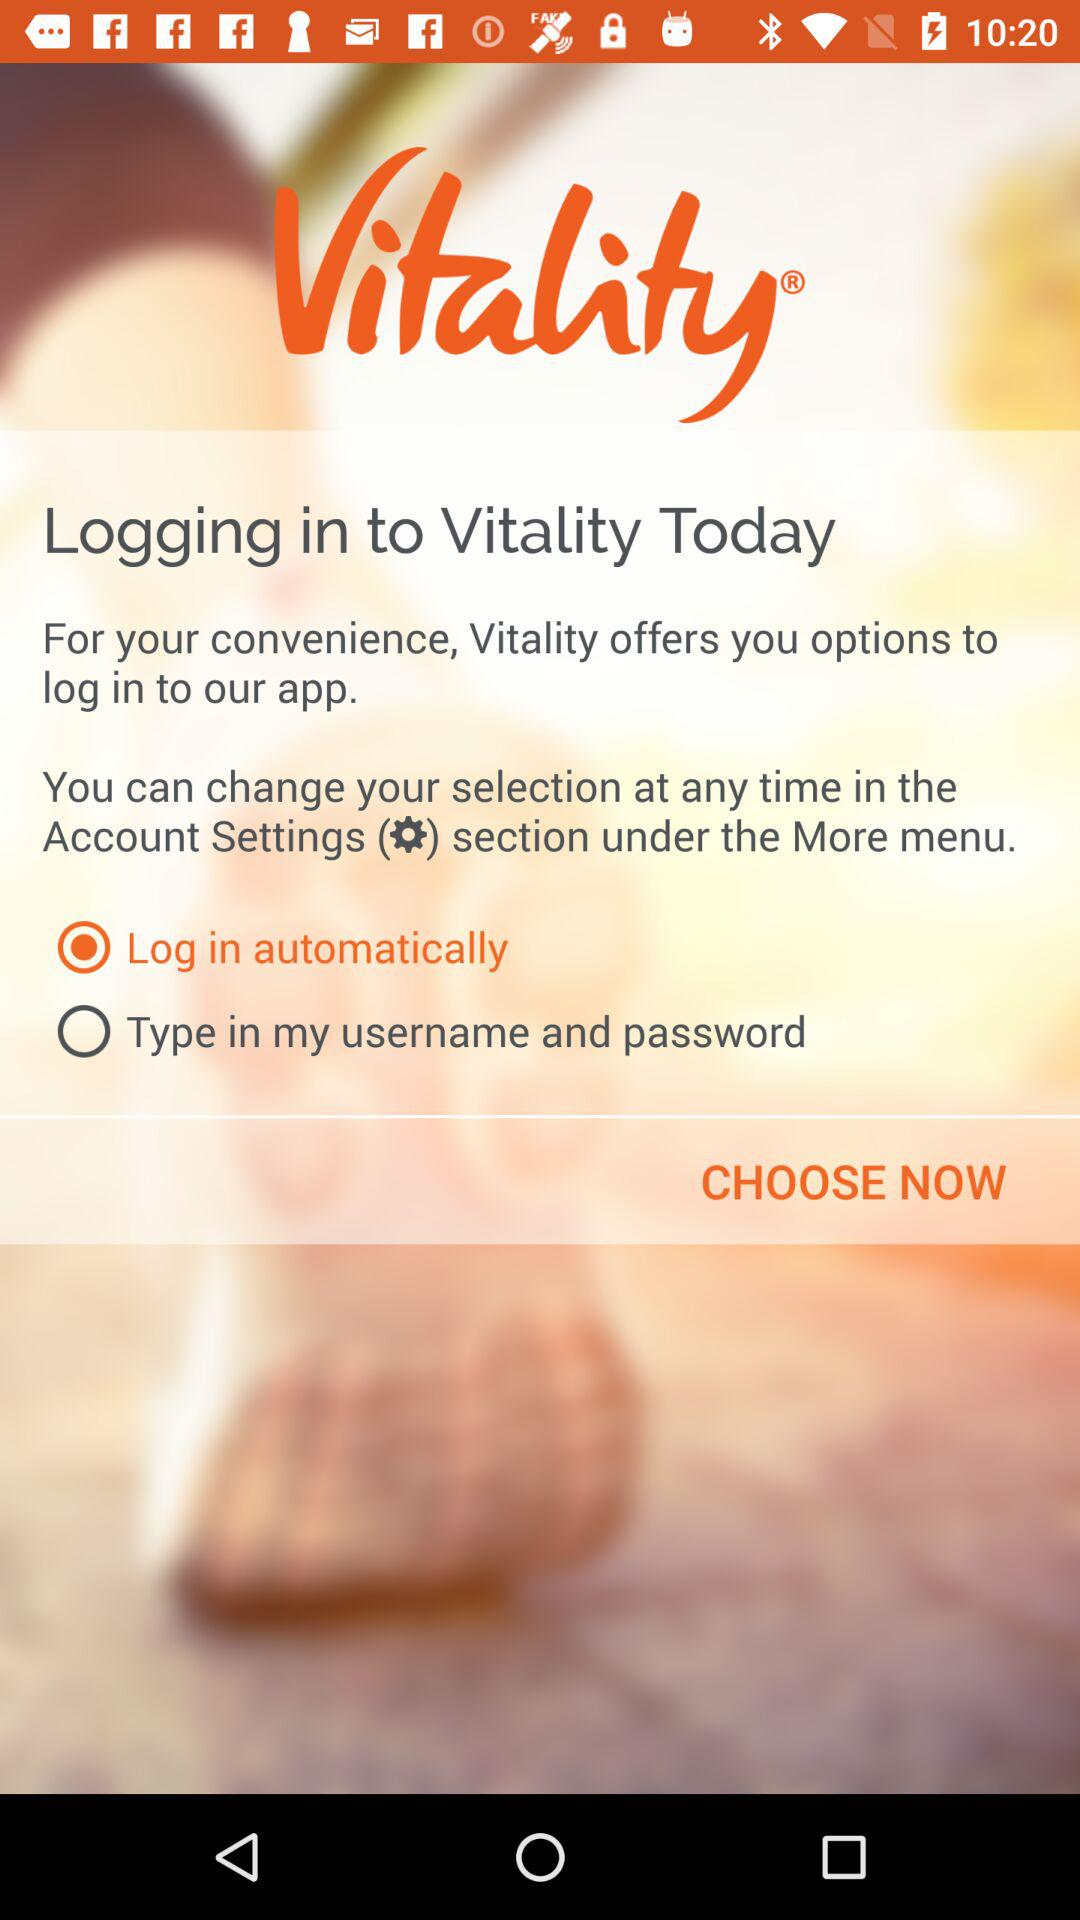How many options are there to log into Vitality?
Answer the question using a single word or phrase. 2 